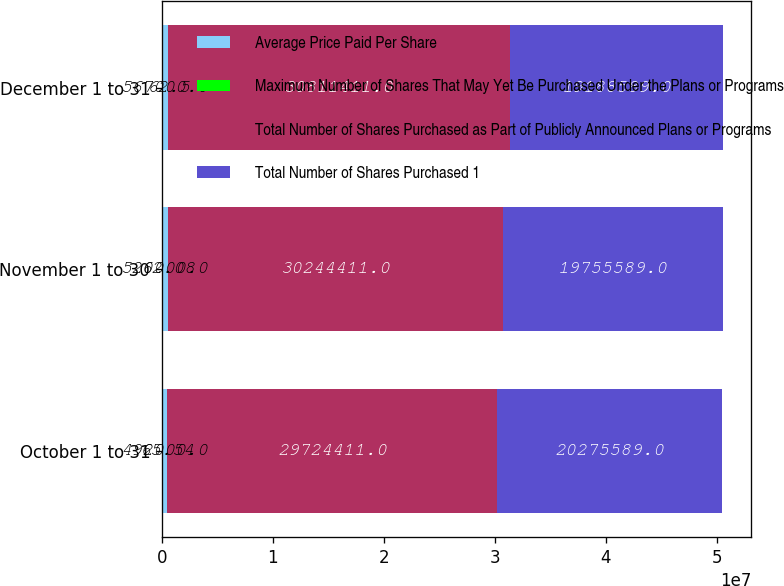Convert chart to OTSL. <chart><loc_0><loc_0><loc_500><loc_500><stacked_bar_chart><ecel><fcel>October 1 to 31<fcel>November 1 to 30<fcel>December 1 to 31<nl><fcel>Average Price Paid Per Share<fcel>492000<fcel>520000<fcel>567000<nl><fcel>Maximum Number of Shares That May Yet Be Purchased Under the Plans or Programs<fcel>65.54<fcel>62.08<fcel>62.5<nl><fcel>Total Number of Shares Purchased as Part of Publicly Announced Plans or Programs<fcel>2.97244e+07<fcel>3.02444e+07<fcel>3.08114e+07<nl><fcel>Total Number of Shares Purchased 1<fcel>2.02756e+07<fcel>1.97556e+07<fcel>1.91886e+07<nl></chart> 